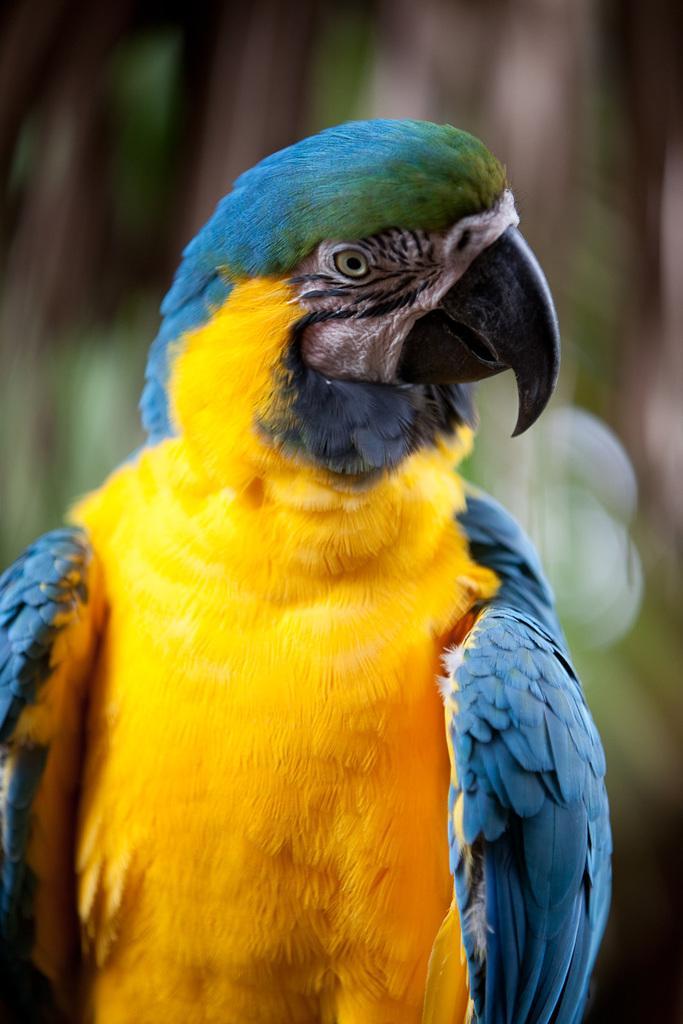Can you describe this image briefly? As we can see in the image in the front there is a yellow and sky blue color bird. The background is blurred. 